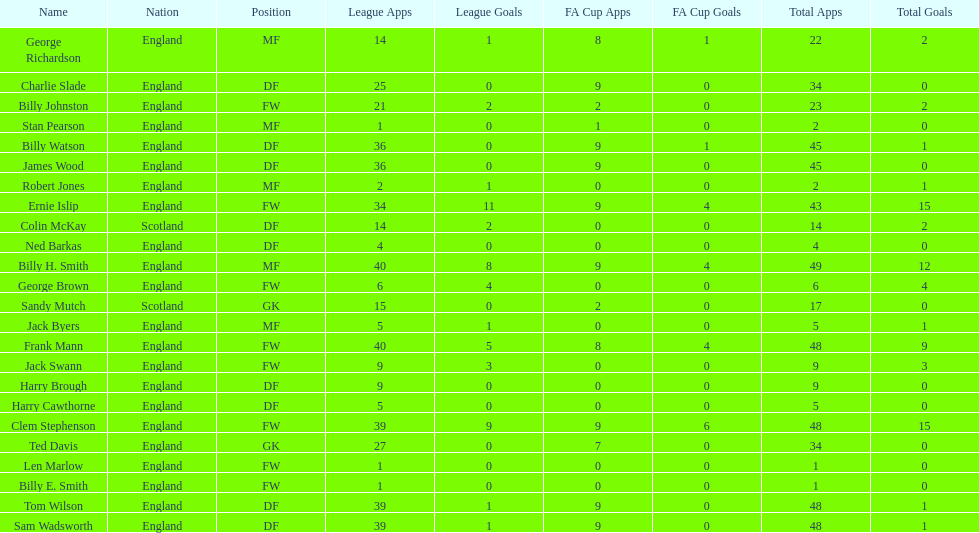What are the number of league apps ted davis has? 27. 